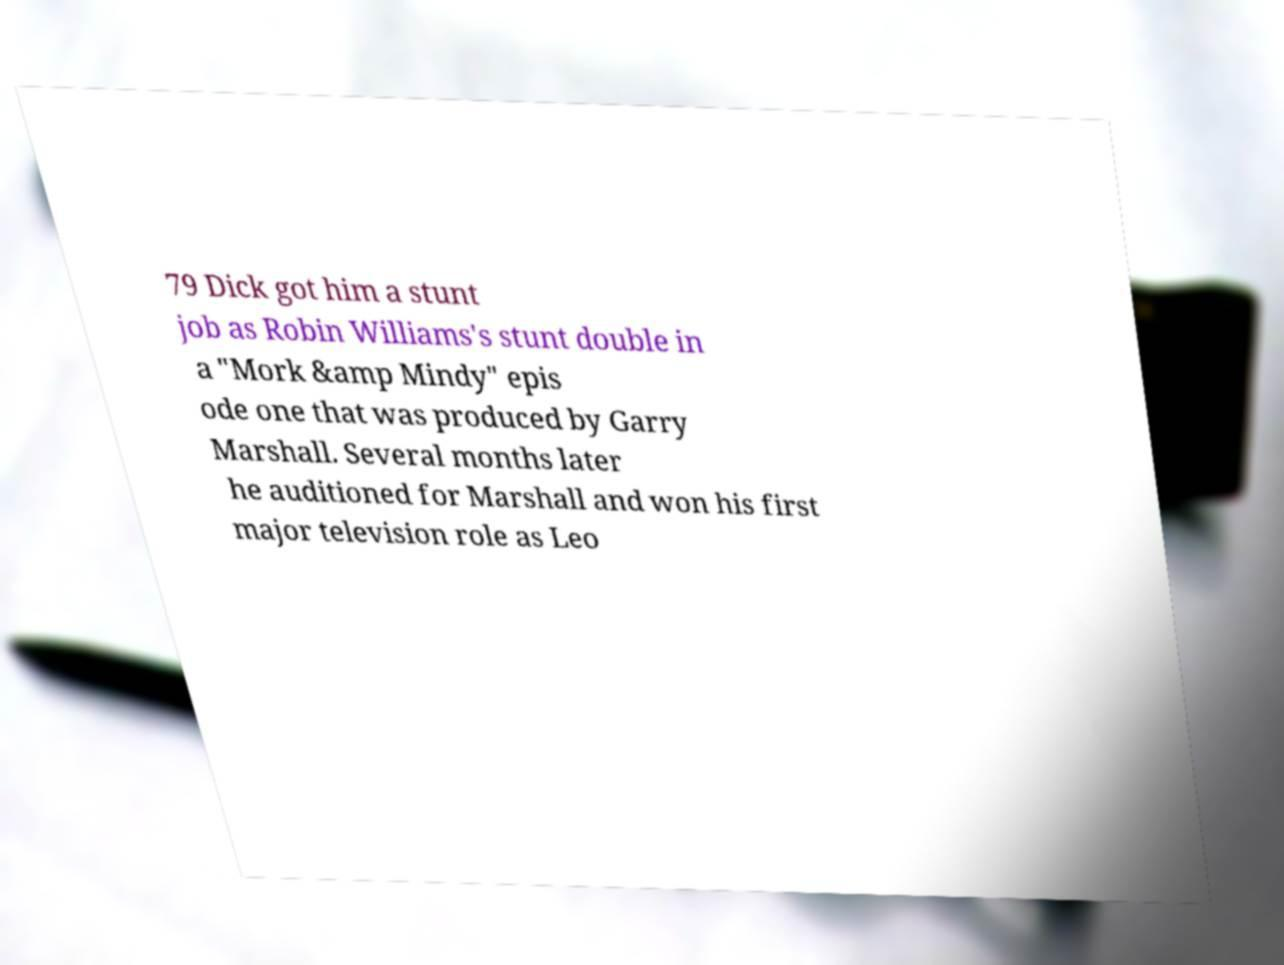Please read and relay the text visible in this image. What does it say? 79 Dick got him a stunt job as Robin Williams's stunt double in a "Mork &amp Mindy" epis ode one that was produced by Garry Marshall. Several months later he auditioned for Marshall and won his first major television role as Leo 